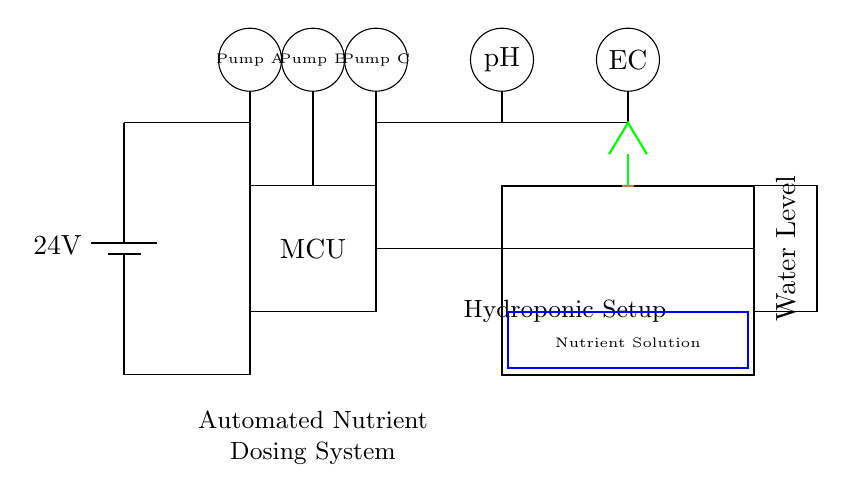What is the main power supply voltage? The circuit specifies a battery with a label showing that its voltage is twenty-four volts.
Answer: twenty-four volts What are the three types of pumps present? The circuit diagram indicates three distinct pumps, labeled as Pump A, Pump B, and Pump C.
Answer: Pump A, Pump B, Pump C How many sensors are included in the system? There are two sensors shown in the circuit diagram, which are the pH sensor and the EC sensor, as well as a water level sensor.
Answer: three sensors What is the function of the microcontroller? The microcontroller, labeled as MCU, serves as the control unit that processes signals from the sensors and operates the pumps accordingly.
Answer: control unit Which sensor is connected to the top left of the microcontroller? The circuit diagrams show that the pH sensor is located at the top left and directly connects to the microcontroller for processing data related to nutrient solutions.
Answer: pH sensor How are the pumps powered in this circuit? The pumps are connected to the main power supply, indicated by the wires shown leading from the battery to each pump, thereby receiving twenty-four volts to operate.
Answer: twenty-four volts What does the blue rectangle represent in the diagram? The blue rectangle within the hydroponic container symbolizes the nutrient solution, indicating where the nutrients are maintained for the plants in the system.
Answer: Nutrient Solution 